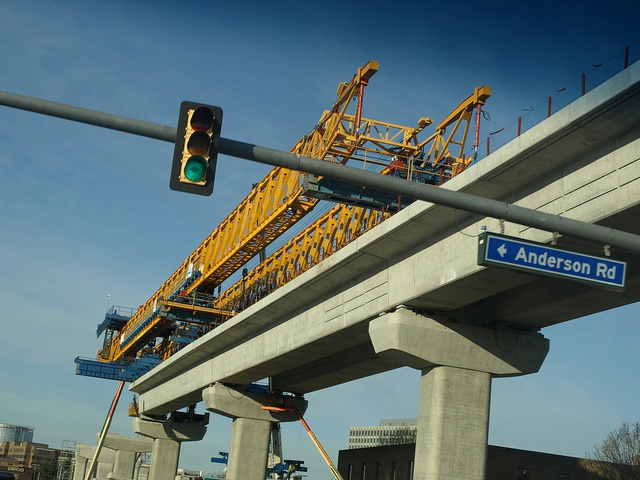Describe the objects in this image and their specific colors. I can see a traffic light in gray, black, teal, maroon, and tan tones in this image. 